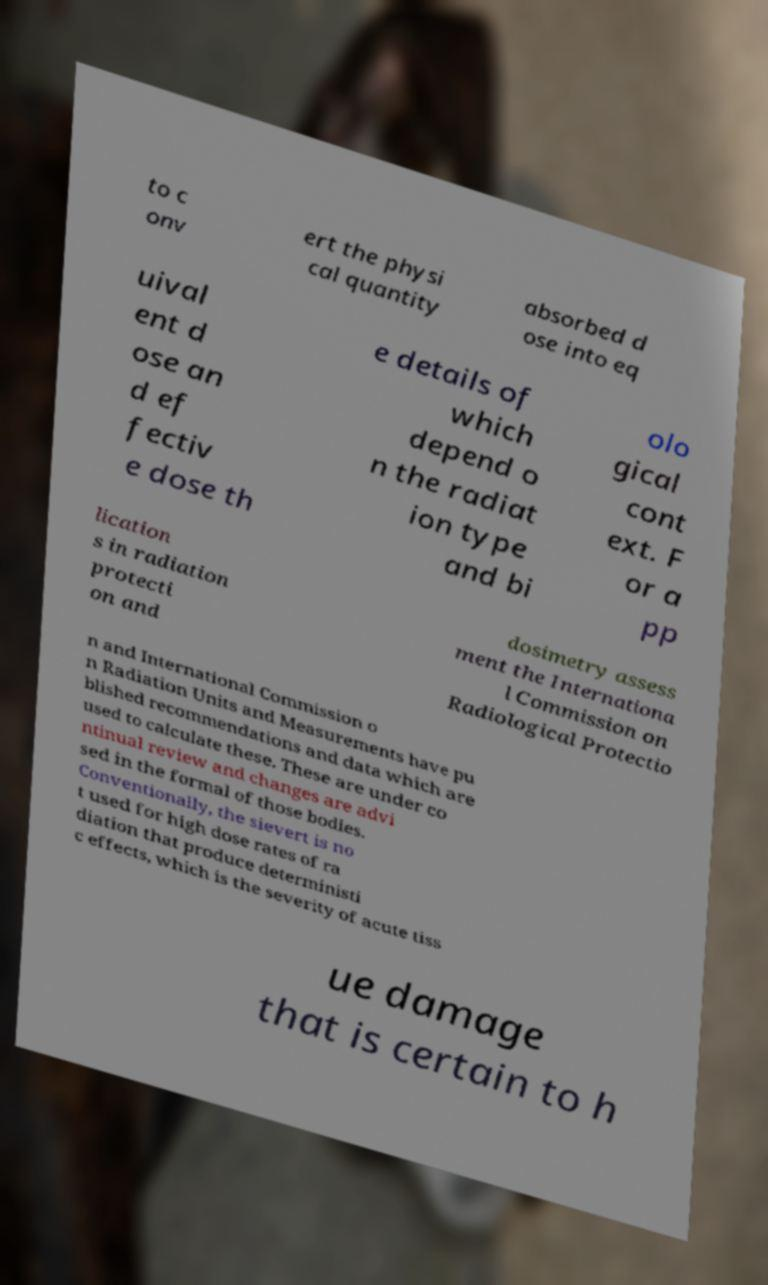For documentation purposes, I need the text within this image transcribed. Could you provide that? to c onv ert the physi cal quantity absorbed d ose into eq uival ent d ose an d ef fectiv e dose th e details of which depend o n the radiat ion type and bi olo gical cont ext. F or a pp lication s in radiation protecti on and dosimetry assess ment the Internationa l Commission on Radiological Protectio n and International Commission o n Radiation Units and Measurements have pu blished recommendations and data which are used to calculate these. These are under co ntinual review and changes are advi sed in the formal of those bodies. Conventionally, the sievert is no t used for high dose rates of ra diation that produce deterministi c effects, which is the severity of acute tiss ue damage that is certain to h 